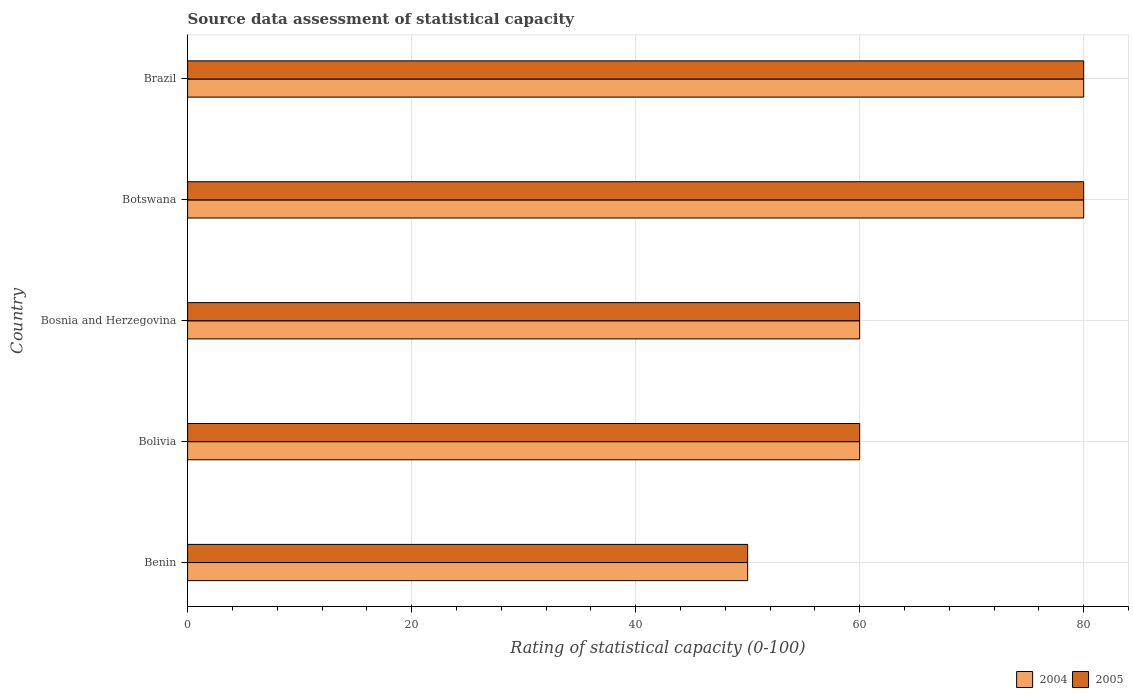How many different coloured bars are there?
Provide a succinct answer. 2. How many groups of bars are there?
Make the answer very short. 5. How many bars are there on the 5th tick from the top?
Your answer should be compact. 2. What is the rating of statistical capacity in 2005 in Bosnia and Herzegovina?
Give a very brief answer. 60. Across all countries, what is the maximum rating of statistical capacity in 2005?
Provide a short and direct response. 80. In which country was the rating of statistical capacity in 2004 maximum?
Offer a terse response. Botswana. In which country was the rating of statistical capacity in 2005 minimum?
Keep it short and to the point. Benin. What is the total rating of statistical capacity in 2005 in the graph?
Give a very brief answer. 330. What is the difference between the rating of statistical capacity in 2004 in Benin and that in Bolivia?
Ensure brevity in your answer.  -10. What is the difference between the rating of statistical capacity in 2004 and rating of statistical capacity in 2005 in Brazil?
Make the answer very short. 0. In how many countries, is the rating of statistical capacity in 2005 greater than 44 ?
Provide a short and direct response. 5. What is the difference between the highest and the second highest rating of statistical capacity in 2005?
Provide a short and direct response. 0. What is the difference between the highest and the lowest rating of statistical capacity in 2004?
Your answer should be compact. 30. Is the sum of the rating of statistical capacity in 2005 in Benin and Botswana greater than the maximum rating of statistical capacity in 2004 across all countries?
Ensure brevity in your answer.  Yes. What does the 2nd bar from the top in Botswana represents?
Your answer should be compact. 2004. How many bars are there?
Your answer should be compact. 10. How many countries are there in the graph?
Your response must be concise. 5. What is the difference between two consecutive major ticks on the X-axis?
Ensure brevity in your answer.  20. Are the values on the major ticks of X-axis written in scientific E-notation?
Keep it short and to the point. No. Does the graph contain any zero values?
Give a very brief answer. No. Does the graph contain grids?
Your answer should be compact. Yes. Where does the legend appear in the graph?
Your answer should be compact. Bottom right. How are the legend labels stacked?
Give a very brief answer. Horizontal. What is the title of the graph?
Ensure brevity in your answer.  Source data assessment of statistical capacity. What is the label or title of the X-axis?
Offer a terse response. Rating of statistical capacity (0-100). What is the Rating of statistical capacity (0-100) in 2004 in Bolivia?
Ensure brevity in your answer.  60. What is the Rating of statistical capacity (0-100) in 2004 in Botswana?
Offer a terse response. 80. What is the Rating of statistical capacity (0-100) in 2004 in Brazil?
Make the answer very short. 80. What is the Rating of statistical capacity (0-100) of 2005 in Brazil?
Ensure brevity in your answer.  80. Across all countries, what is the maximum Rating of statistical capacity (0-100) of 2004?
Make the answer very short. 80. Across all countries, what is the maximum Rating of statistical capacity (0-100) of 2005?
Provide a succinct answer. 80. What is the total Rating of statistical capacity (0-100) of 2004 in the graph?
Keep it short and to the point. 330. What is the total Rating of statistical capacity (0-100) of 2005 in the graph?
Provide a succinct answer. 330. What is the difference between the Rating of statistical capacity (0-100) in 2004 in Benin and that in Bolivia?
Make the answer very short. -10. What is the difference between the Rating of statistical capacity (0-100) in 2005 in Benin and that in Botswana?
Provide a short and direct response. -30. What is the difference between the Rating of statistical capacity (0-100) in 2004 in Benin and that in Brazil?
Ensure brevity in your answer.  -30. What is the difference between the Rating of statistical capacity (0-100) of 2005 in Benin and that in Brazil?
Give a very brief answer. -30. What is the difference between the Rating of statistical capacity (0-100) of 2004 in Bolivia and that in Botswana?
Your answer should be very brief. -20. What is the difference between the Rating of statistical capacity (0-100) in 2005 in Bolivia and that in Botswana?
Offer a very short reply. -20. What is the difference between the Rating of statistical capacity (0-100) of 2004 in Bolivia and that in Brazil?
Provide a short and direct response. -20. What is the difference between the Rating of statistical capacity (0-100) in 2005 in Bolivia and that in Brazil?
Your answer should be very brief. -20. What is the difference between the Rating of statistical capacity (0-100) in 2004 in Bosnia and Herzegovina and that in Brazil?
Make the answer very short. -20. What is the difference between the Rating of statistical capacity (0-100) in 2005 in Bosnia and Herzegovina and that in Brazil?
Provide a short and direct response. -20. What is the difference between the Rating of statistical capacity (0-100) in 2004 in Botswana and that in Brazil?
Give a very brief answer. 0. What is the difference between the Rating of statistical capacity (0-100) in 2005 in Botswana and that in Brazil?
Offer a very short reply. 0. What is the difference between the Rating of statistical capacity (0-100) of 2004 in Benin and the Rating of statistical capacity (0-100) of 2005 in Bolivia?
Your answer should be very brief. -10. What is the difference between the Rating of statistical capacity (0-100) in 2004 in Benin and the Rating of statistical capacity (0-100) in 2005 in Bosnia and Herzegovina?
Provide a short and direct response. -10. What is the difference between the Rating of statistical capacity (0-100) of 2004 in Benin and the Rating of statistical capacity (0-100) of 2005 in Botswana?
Give a very brief answer. -30. What is the difference between the Rating of statistical capacity (0-100) of 2004 in Benin and the Rating of statistical capacity (0-100) of 2005 in Brazil?
Make the answer very short. -30. What is the difference between the Rating of statistical capacity (0-100) of 2004 in Bolivia and the Rating of statistical capacity (0-100) of 2005 in Bosnia and Herzegovina?
Keep it short and to the point. 0. What is the difference between the Rating of statistical capacity (0-100) of 2004 in Bolivia and the Rating of statistical capacity (0-100) of 2005 in Brazil?
Your answer should be very brief. -20. What is the difference between the Rating of statistical capacity (0-100) of 2004 in Botswana and the Rating of statistical capacity (0-100) of 2005 in Brazil?
Provide a short and direct response. 0. What is the average Rating of statistical capacity (0-100) in 2005 per country?
Offer a very short reply. 66. What is the difference between the Rating of statistical capacity (0-100) in 2004 and Rating of statistical capacity (0-100) in 2005 in Benin?
Your response must be concise. 0. What is the difference between the Rating of statistical capacity (0-100) in 2004 and Rating of statistical capacity (0-100) in 2005 in Bosnia and Herzegovina?
Your answer should be very brief. 0. What is the difference between the Rating of statistical capacity (0-100) of 2004 and Rating of statistical capacity (0-100) of 2005 in Brazil?
Your answer should be compact. 0. What is the ratio of the Rating of statistical capacity (0-100) in 2005 in Benin to that in Bosnia and Herzegovina?
Keep it short and to the point. 0.83. What is the ratio of the Rating of statistical capacity (0-100) of 2004 in Benin to that in Botswana?
Give a very brief answer. 0.62. What is the ratio of the Rating of statistical capacity (0-100) in 2004 in Benin to that in Brazil?
Your answer should be compact. 0.62. What is the ratio of the Rating of statistical capacity (0-100) in 2005 in Bolivia to that in Bosnia and Herzegovina?
Your response must be concise. 1. What is the ratio of the Rating of statistical capacity (0-100) in 2004 in Bosnia and Herzegovina to that in Botswana?
Keep it short and to the point. 0.75. What is the ratio of the Rating of statistical capacity (0-100) in 2004 in Bosnia and Herzegovina to that in Brazil?
Provide a short and direct response. 0.75. What is the ratio of the Rating of statistical capacity (0-100) of 2004 in Botswana to that in Brazil?
Keep it short and to the point. 1. What is the difference between the highest and the second highest Rating of statistical capacity (0-100) of 2004?
Provide a succinct answer. 0. What is the difference between the highest and the lowest Rating of statistical capacity (0-100) of 2005?
Offer a very short reply. 30. 